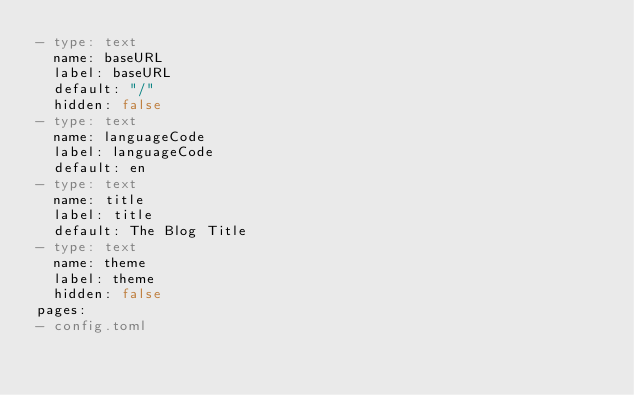<code> <loc_0><loc_0><loc_500><loc_500><_YAML_>- type: text
  name: baseURL
  label: baseURL
  default: "/"
  hidden: false
- type: text
  name: languageCode
  label: languageCode
  default: en
- type: text
  name: title
  label: title
  default: The Blog Title
- type: text
  name: theme
  label: theme
  hidden: false
pages:
- config.toml
</code> 